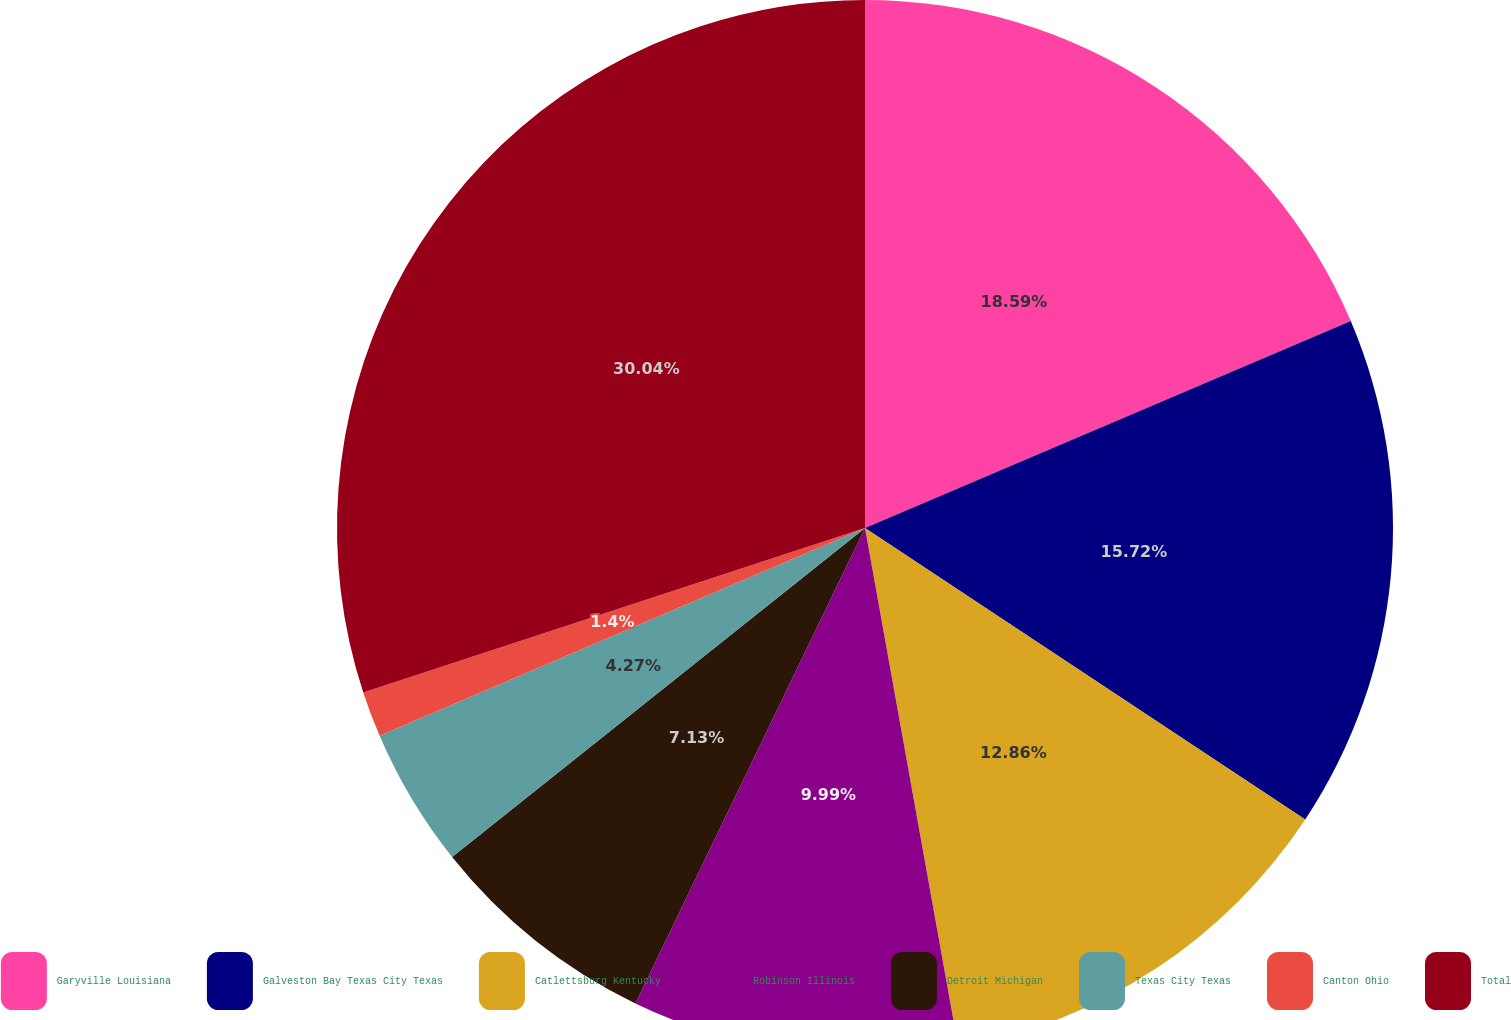<chart> <loc_0><loc_0><loc_500><loc_500><pie_chart><fcel>Garyville Louisiana<fcel>Galveston Bay Texas City Texas<fcel>Catlettsburg Kentucky<fcel>Robinson Illinois<fcel>Detroit Michigan<fcel>Texas City Texas<fcel>Canton Ohio<fcel>Total<nl><fcel>18.59%<fcel>15.72%<fcel>12.86%<fcel>9.99%<fcel>7.13%<fcel>4.27%<fcel>1.4%<fcel>30.04%<nl></chart> 